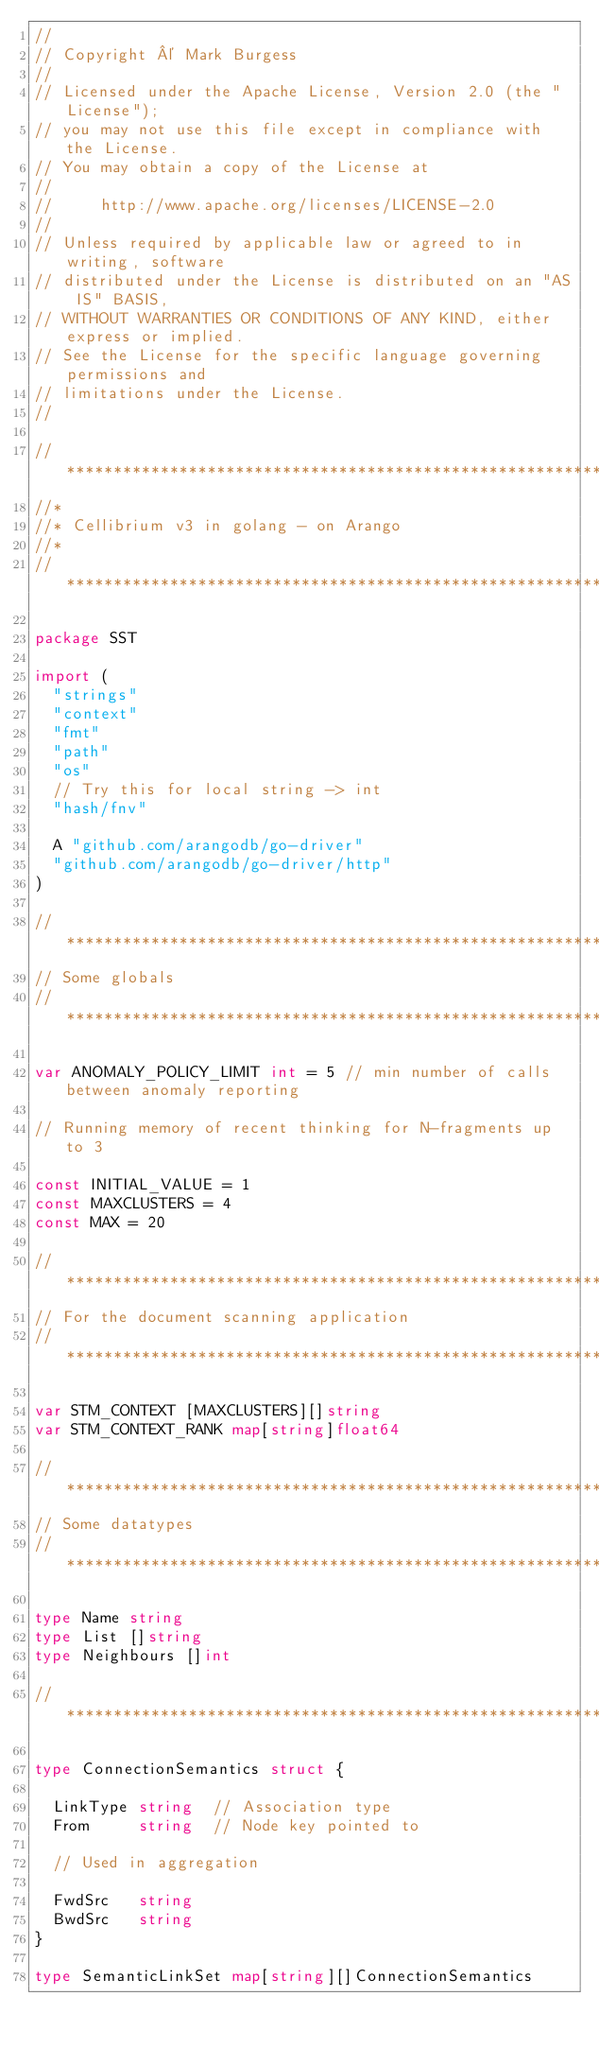<code> <loc_0><loc_0><loc_500><loc_500><_Go_>//
// Copyright © Mark Burgess
//
// Licensed under the Apache License, Version 2.0 (the "License");
// you may not use this file except in compliance with the License.
// You may obtain a copy of the License at
//
//     http://www.apache.org/licenses/LICENSE-2.0
//
// Unless required by applicable law or agreed to in writing, software
// distributed under the License is distributed on an "AS IS" BASIS,
// WITHOUT WARRANTIES OR CONDITIONS OF ANY KIND, either express or implied.
// See the License for the specific language governing permissions and
// limitations under the License.
//

// ***************************************************************************
//*
//* Cellibrium v3 in golang - on Arango
//*
// ***************************************************************************

package SST

import (
	"strings"
	"context"
	"fmt"
	"path"
	"os"
	// Try this for local string -> int
	"hash/fnv"

	A "github.com/arangodb/go-driver"
	"github.com/arangodb/go-driver/http"
)

// ***************************************************************************
// Some globals
// ***************************************************************************

var ANOMALY_POLICY_LIMIT int = 5 // min number of calls between anomaly reporting

// Running memory of recent thinking for N-fragments up to 3

const INITIAL_VALUE = 1
const MAXCLUSTERS = 4
const MAX = 20

// ***************************************************************************
// For the document scanning application
// ***************************************************************************

var STM_CONTEXT [MAXCLUSTERS][]string
var STM_CONTEXT_RANK map[string]float64

// ***************************************************************************
// Some datatypes
// ***************************************************************************

type Name string
type List []string
type Neighbours []int

// ****************************************************************************

type ConnectionSemantics struct {

	LinkType string  // Association type
	From     string  // Node key pointed to

	// Used in aggregation

	FwdSrc   string
	BwdSrc   string
}

type SemanticLinkSet map[string][]ConnectionSemantics
</code> 